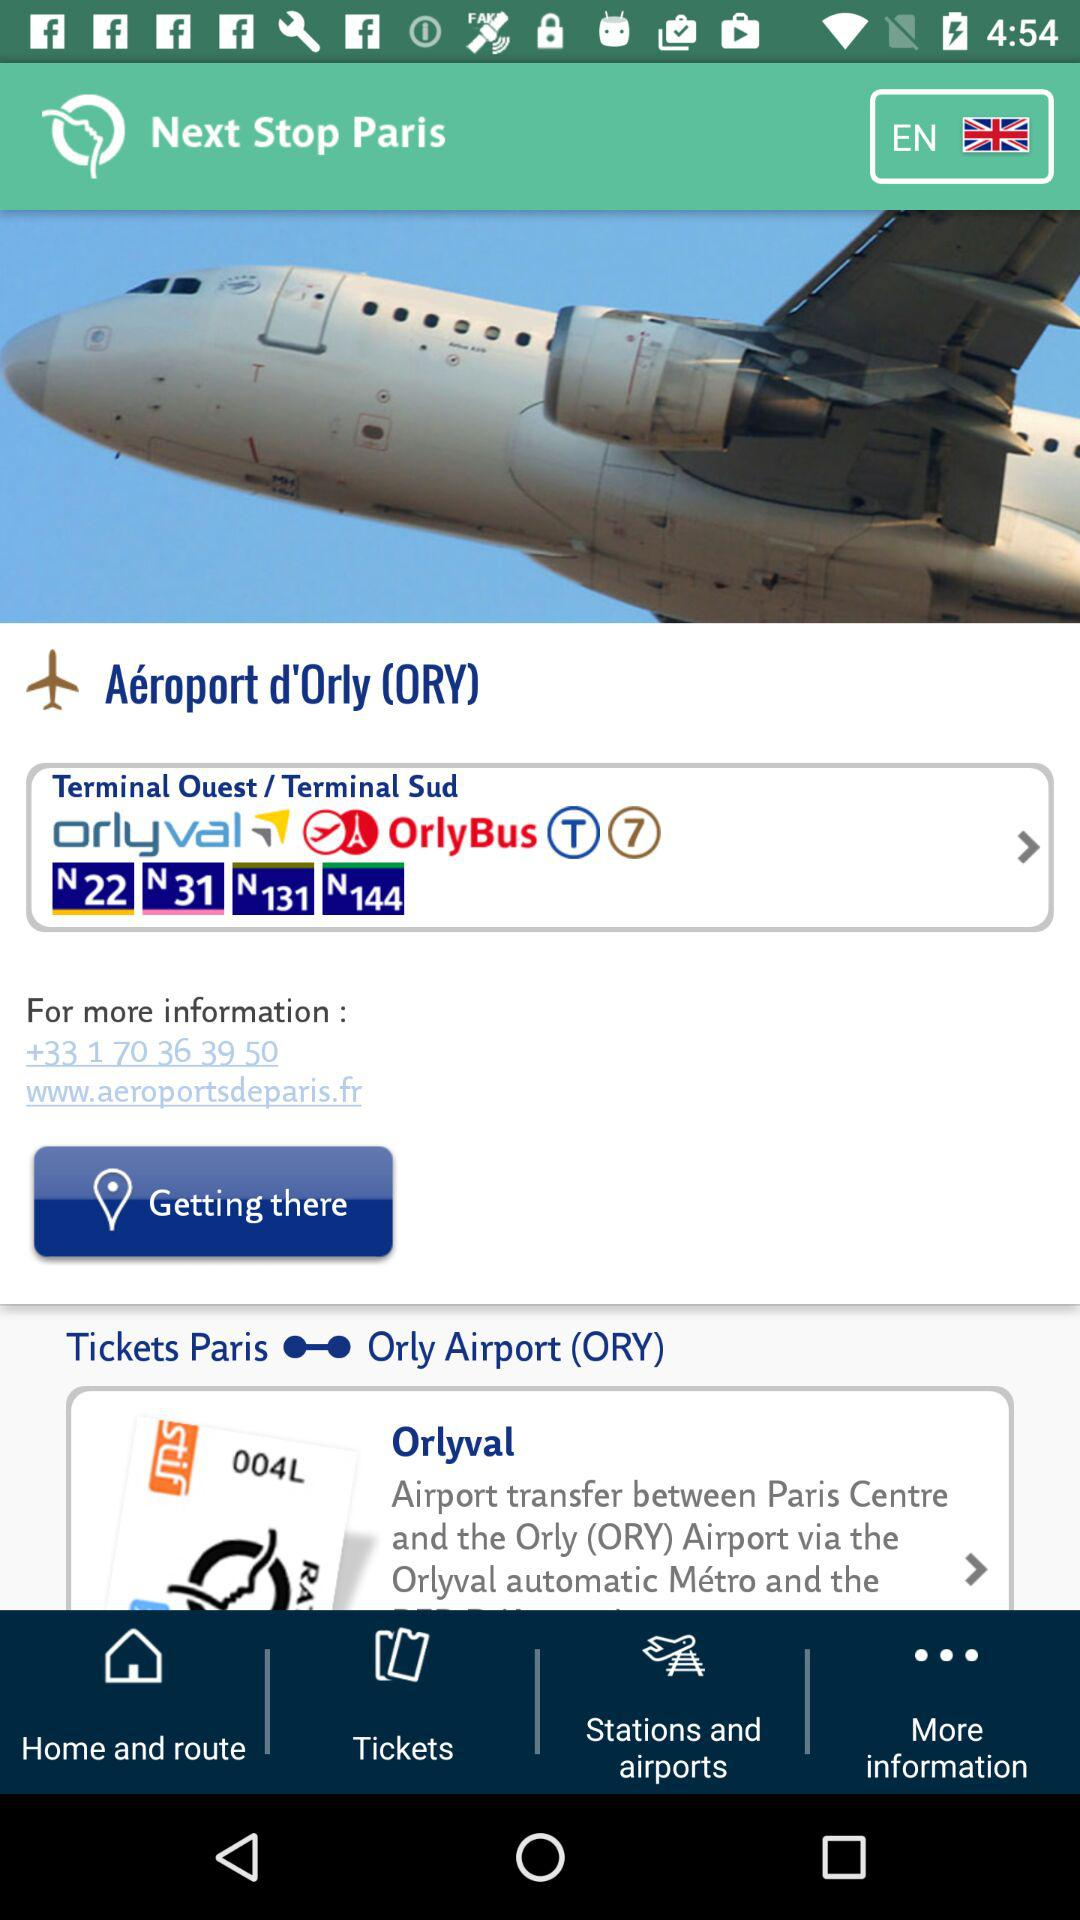What is the current location?
When the provided information is insufficient, respond with <no answer>. <no answer> 